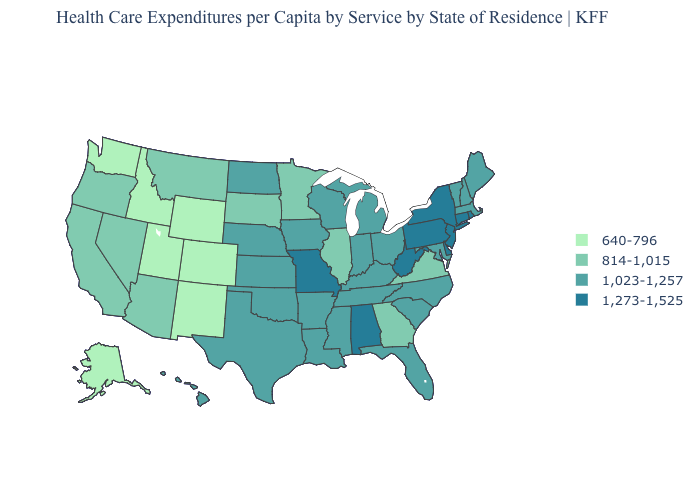Is the legend a continuous bar?
Quick response, please. No. Which states hav the highest value in the West?
Keep it brief. Hawaii. What is the lowest value in the USA?
Quick response, please. 640-796. Does Illinois have the highest value in the MidWest?
Quick response, please. No. What is the lowest value in the USA?
Be succinct. 640-796. Which states have the highest value in the USA?
Write a very short answer. Alabama, Connecticut, Delaware, Missouri, New Jersey, New York, Pennsylvania, Rhode Island, West Virginia. Does Indiana have the same value as Ohio?
Be succinct. Yes. How many symbols are there in the legend?
Short answer required. 4. What is the value of Oklahoma?
Short answer required. 1,023-1,257. Name the states that have a value in the range 1,273-1,525?
Concise answer only. Alabama, Connecticut, Delaware, Missouri, New Jersey, New York, Pennsylvania, Rhode Island, West Virginia. What is the highest value in the USA?
Give a very brief answer. 1,273-1,525. Name the states that have a value in the range 814-1,015?
Give a very brief answer. Arizona, California, Georgia, Illinois, Minnesota, Montana, Nevada, Oregon, South Dakota, Virginia. What is the value of Louisiana?
Answer briefly. 1,023-1,257. What is the value of Michigan?
Answer briefly. 1,023-1,257. Does Arizona have the lowest value in the USA?
Short answer required. No. 